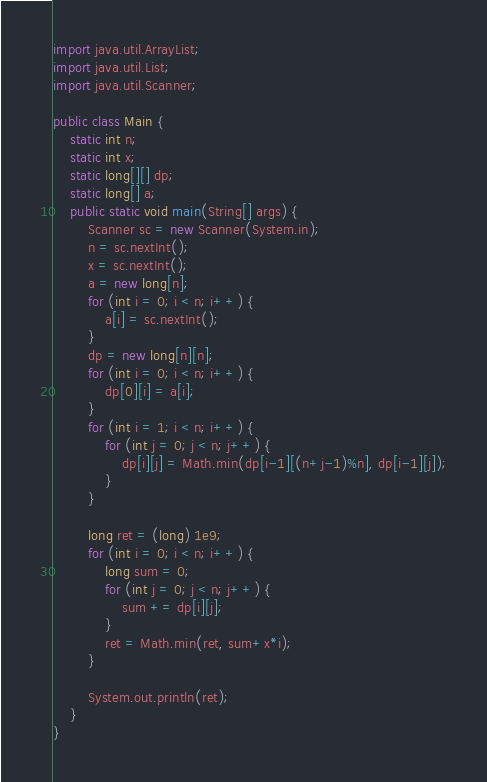Convert code to text. <code><loc_0><loc_0><loc_500><loc_500><_Java_>import java.util.ArrayList;
import java.util.List;
import java.util.Scanner;

public class Main {
    static int n;
    static int x;
    static long[][] dp;
    static long[] a;
    public static void main(String[] args) {
        Scanner sc = new Scanner(System.in);
        n = sc.nextInt();
        x = sc.nextInt();
        a = new long[n];
        for (int i = 0; i < n; i++) {
            a[i] = sc.nextInt();
        }
        dp = new long[n][n];
        for (int i = 0; i < n; i++) {
            dp[0][i] = a[i];
        }
        for (int i = 1; i < n; i++) {
            for (int j = 0; j < n; j++) {
                dp[i][j] = Math.min(dp[i-1][(n+j-1)%n], dp[i-1][j]);
            }
        }

        long ret = (long) 1e9;
        for (int i = 0; i < n; i++) {
            long sum = 0;
            for (int j = 0; j < n; j++) {
                sum += dp[i][j];
            }
            ret = Math.min(ret, sum+x*i);
        }

        System.out.println(ret);
    }
}</code> 